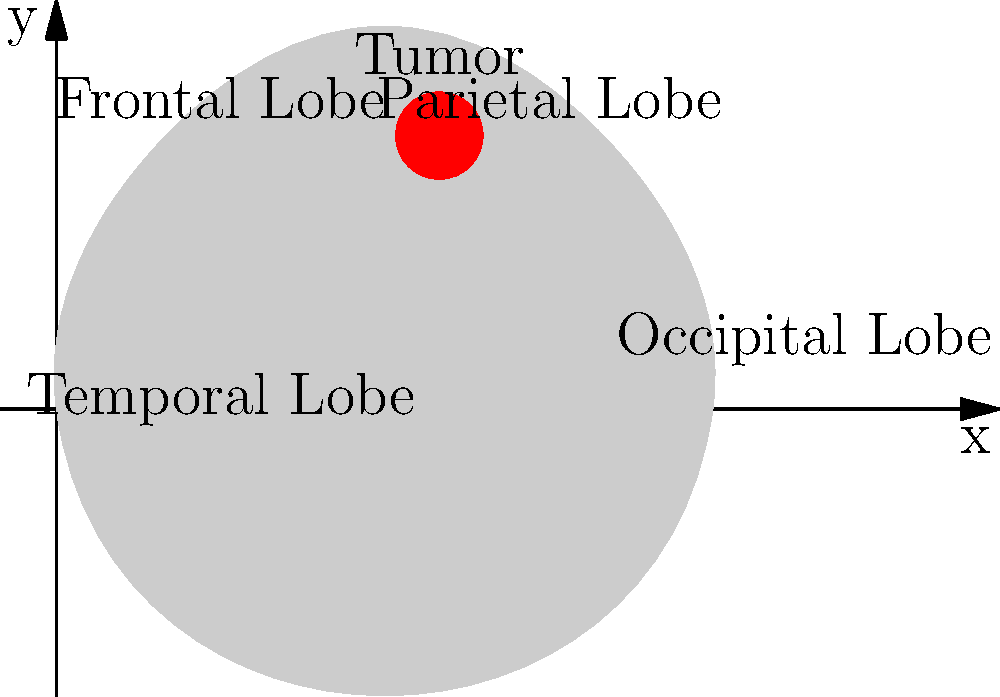Based on the MRI scan representation shown above, in which lobe of the brain is the tumor primarily located? To identify the correct location of the brain tumor based on the MRI scan representation, we need to follow these steps:

1. Observe the graphical representation of the brain, which shows a simplified outline of the cerebral hemispheres.

2. Note the labeled regions of the brain:
   - Frontal Lobe: Located in the anterior (front) portion of the brain
   - Parietal Lobe: Located posterior to the frontal lobe, in the upper rear portion
   - Temporal Lobe: Located in the lower lateral portions of the brain
   - Occipital Lobe: Located in the posterior (rear) portion of the brain

3. Identify the tumor, which is represented by the red circular area in the image.

4. Analyze the position of the tumor relative to the labeled regions:
   - The tumor is situated in the upper middle portion of the brain outline
   - It is posterior to the area labeled "Frontal Lobe"
   - It is anterior to the area labeled "Occipital Lobe"
   - It is superior to the area labeled "Temporal Lobe"
   - It is within the region labeled "Parietal Lobe"

5. Based on this analysis, we can conclude that the tumor is primarily located in the Parietal Lobe.

This location is consistent with the traditional neuroanatomical understanding of brain structure and function, which is crucial for a neurosurgeon with a traditional view on neurological conditions.
Answer: Parietal Lobe 